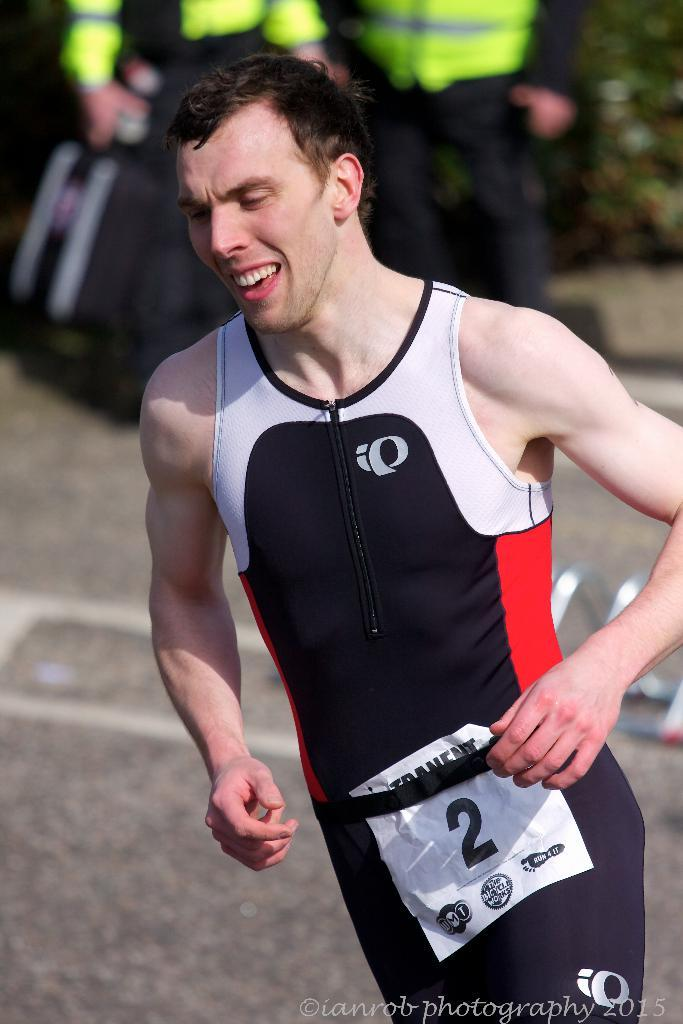Provide a one-sentence caption for the provided image. Athlete number 2 wears a black body suit with red and white accents. 